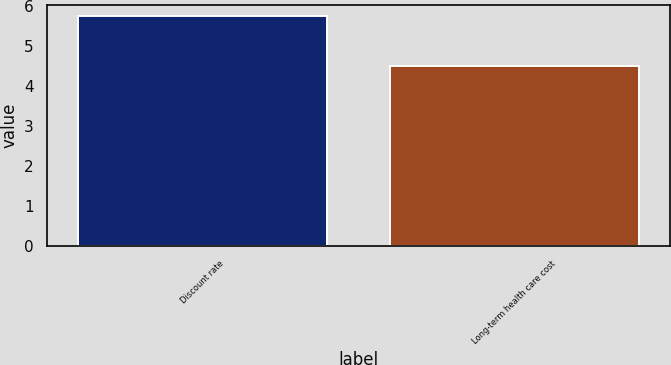<chart> <loc_0><loc_0><loc_500><loc_500><bar_chart><fcel>Discount rate<fcel>Long-term health care cost<nl><fcel>5.75<fcel>4.5<nl></chart> 